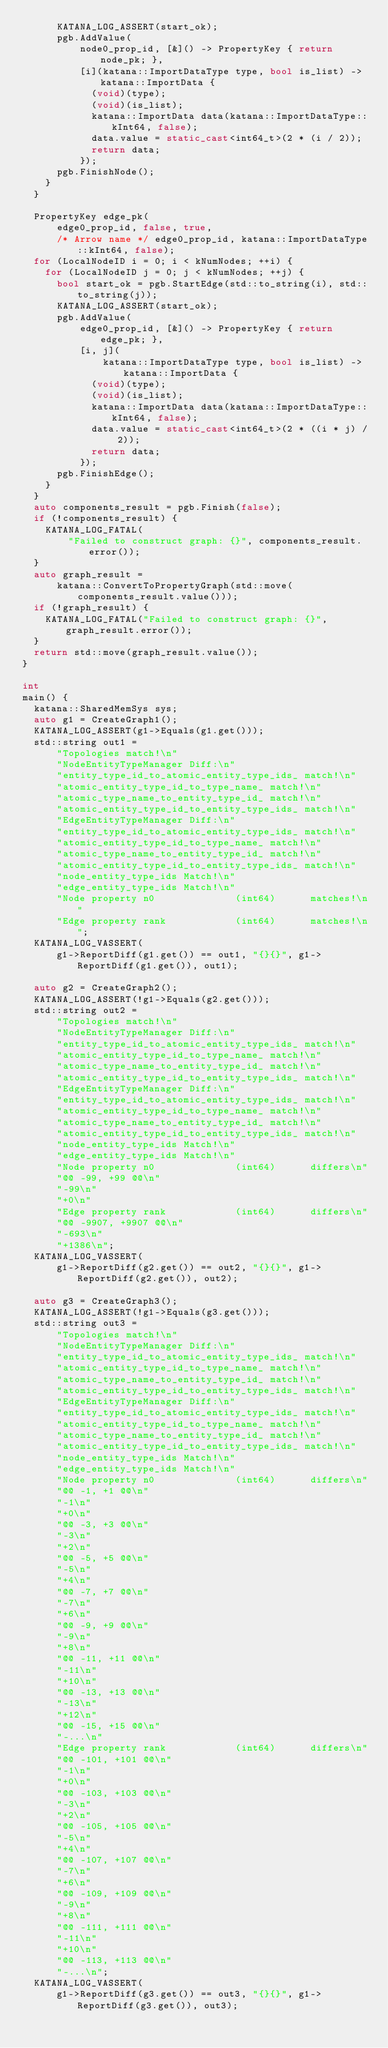<code> <loc_0><loc_0><loc_500><loc_500><_C++_>      KATANA_LOG_ASSERT(start_ok);
      pgb.AddValue(
          node0_prop_id, [&]() -> PropertyKey { return node_pk; },
          [i](katana::ImportDataType type, bool is_list) -> katana::ImportData {
            (void)(type);
            (void)(is_list);
            katana::ImportData data(katana::ImportDataType::kInt64, false);
            data.value = static_cast<int64_t>(2 * (i / 2));
            return data;
          });
      pgb.FinishNode();
    }
  }

  PropertyKey edge_pk(
      edge0_prop_id, false, true,
      /* Arrow name */ edge0_prop_id, katana::ImportDataType::kInt64, false);
  for (LocalNodeID i = 0; i < kNumNodes; ++i) {
    for (LocalNodeID j = 0; j < kNumNodes; ++j) {
      bool start_ok = pgb.StartEdge(std::to_string(i), std::to_string(j));
      KATANA_LOG_ASSERT(start_ok);
      pgb.AddValue(
          edge0_prop_id, [&]() -> PropertyKey { return edge_pk; },
          [i, j](
              katana::ImportDataType type, bool is_list) -> katana::ImportData {
            (void)(type);
            (void)(is_list);
            katana::ImportData data(katana::ImportDataType::kInt64, false);
            data.value = static_cast<int64_t>(2 * ((i * j) / 2));
            return data;
          });
      pgb.FinishEdge();
    }
  }
  auto components_result = pgb.Finish(false);
  if (!components_result) {
    KATANA_LOG_FATAL(
        "Failed to construct graph: {}", components_result.error());
  }
  auto graph_result =
      katana::ConvertToPropertyGraph(std::move(components_result.value()));
  if (!graph_result) {
    KATANA_LOG_FATAL("Failed to construct graph: {}", graph_result.error());
  }
  return std::move(graph_result.value());
}

int
main() {
  katana::SharedMemSys sys;
  auto g1 = CreateGraph1();
  KATANA_LOG_ASSERT(g1->Equals(g1.get()));
  std::string out1 =
      "Topologies match!\n"
      "NodeEntityTypeManager Diff:\n"
      "entity_type_id_to_atomic_entity_type_ids_ match!\n"
      "atomic_entity_type_id_to_type_name_ match!\n"
      "atomic_type_name_to_entity_type_id_ match!\n"
      "atomic_entity_type_id_to_entity_type_ids_ match!\n"
      "EdgeEntityTypeManager Diff:\n"
      "entity_type_id_to_atomic_entity_type_ids_ match!\n"
      "atomic_entity_type_id_to_type_name_ match!\n"
      "atomic_type_name_to_entity_type_id_ match!\n"
      "atomic_entity_type_id_to_entity_type_ids_ match!\n"
      "node_entity_type_ids Match!\n"
      "edge_entity_type_ids Match!\n"
      "Node property n0              (int64)      matches!\n"
      "Edge property rank            (int64)      matches!\n";
  KATANA_LOG_VASSERT(
      g1->ReportDiff(g1.get()) == out1, "{}{}", g1->ReportDiff(g1.get()), out1);

  auto g2 = CreateGraph2();
  KATANA_LOG_ASSERT(!g1->Equals(g2.get()));
  std::string out2 =
      "Topologies match!\n"
      "NodeEntityTypeManager Diff:\n"
      "entity_type_id_to_atomic_entity_type_ids_ match!\n"
      "atomic_entity_type_id_to_type_name_ match!\n"
      "atomic_type_name_to_entity_type_id_ match!\n"
      "atomic_entity_type_id_to_entity_type_ids_ match!\n"
      "EdgeEntityTypeManager Diff:\n"
      "entity_type_id_to_atomic_entity_type_ids_ match!\n"
      "atomic_entity_type_id_to_type_name_ match!\n"
      "atomic_type_name_to_entity_type_id_ match!\n"
      "atomic_entity_type_id_to_entity_type_ids_ match!\n"
      "node_entity_type_ids Match!\n"
      "edge_entity_type_ids Match!\n"
      "Node property n0              (int64)      differs\n"
      "@@ -99, +99 @@\n"
      "-99\n"
      "+0\n"
      "Edge property rank            (int64)      differs\n"
      "@@ -9907, +9907 @@\n"
      "-693\n"
      "+1386\n";
  KATANA_LOG_VASSERT(
      g1->ReportDiff(g2.get()) == out2, "{}{}", g1->ReportDiff(g2.get()), out2);

  auto g3 = CreateGraph3();
  KATANA_LOG_ASSERT(!g1->Equals(g3.get()));
  std::string out3 =
      "Topologies match!\n"
      "NodeEntityTypeManager Diff:\n"
      "entity_type_id_to_atomic_entity_type_ids_ match!\n"
      "atomic_entity_type_id_to_type_name_ match!\n"
      "atomic_type_name_to_entity_type_id_ match!\n"
      "atomic_entity_type_id_to_entity_type_ids_ match!\n"
      "EdgeEntityTypeManager Diff:\n"
      "entity_type_id_to_atomic_entity_type_ids_ match!\n"
      "atomic_entity_type_id_to_type_name_ match!\n"
      "atomic_type_name_to_entity_type_id_ match!\n"
      "atomic_entity_type_id_to_entity_type_ids_ match!\n"
      "node_entity_type_ids Match!\n"
      "edge_entity_type_ids Match!\n"
      "Node property n0              (int64)      differs\n"
      "@@ -1, +1 @@\n"
      "-1\n"
      "+0\n"
      "@@ -3, +3 @@\n"
      "-3\n"
      "+2\n"
      "@@ -5, +5 @@\n"
      "-5\n"
      "+4\n"
      "@@ -7, +7 @@\n"
      "-7\n"
      "+6\n"
      "@@ -9, +9 @@\n"
      "-9\n"
      "+8\n"
      "@@ -11, +11 @@\n"
      "-11\n"
      "+10\n"
      "@@ -13, +13 @@\n"
      "-13\n"
      "+12\n"
      "@@ -15, +15 @@\n"
      "-...\n"
      "Edge property rank            (int64)      differs\n"
      "@@ -101, +101 @@\n"
      "-1\n"
      "+0\n"
      "@@ -103, +103 @@\n"
      "-3\n"
      "+2\n"
      "@@ -105, +105 @@\n"
      "-5\n"
      "+4\n"
      "@@ -107, +107 @@\n"
      "-7\n"
      "+6\n"
      "@@ -109, +109 @@\n"
      "-9\n"
      "+8\n"
      "@@ -111, +111 @@\n"
      "-11\n"
      "+10\n"
      "@@ -113, +113 @@\n"
      "-...\n";
  KATANA_LOG_VASSERT(
      g1->ReportDiff(g3.get()) == out3, "{}{}", g1->ReportDiff(g3.get()), out3);
</code> 